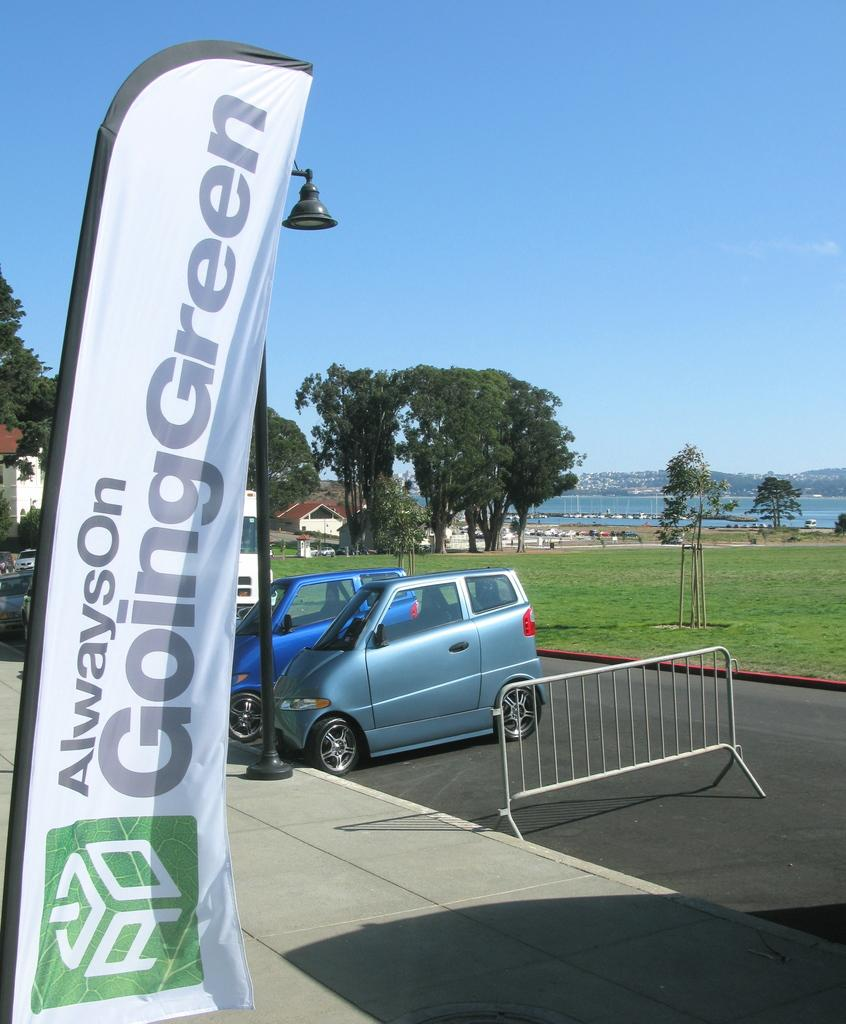What can be seen flying in the image? There is a flag in the image. What type of vehicles are present in the image? There are cars in the image. What natural elements can be seen in the image? There are trees, a river, and mountains in the image. What is the condition of the sky in the image? The sky is clear in the image. How many people are in the crowd in the image? There is no crowd present in the image. What fact can be learned about the police in the image? There is no mention of the police in the image. 